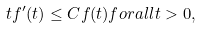<formula> <loc_0><loc_0><loc_500><loc_500>t f ^ { \prime } ( t ) \leq C f ( t ) f o r a l l t > 0 ,</formula> 